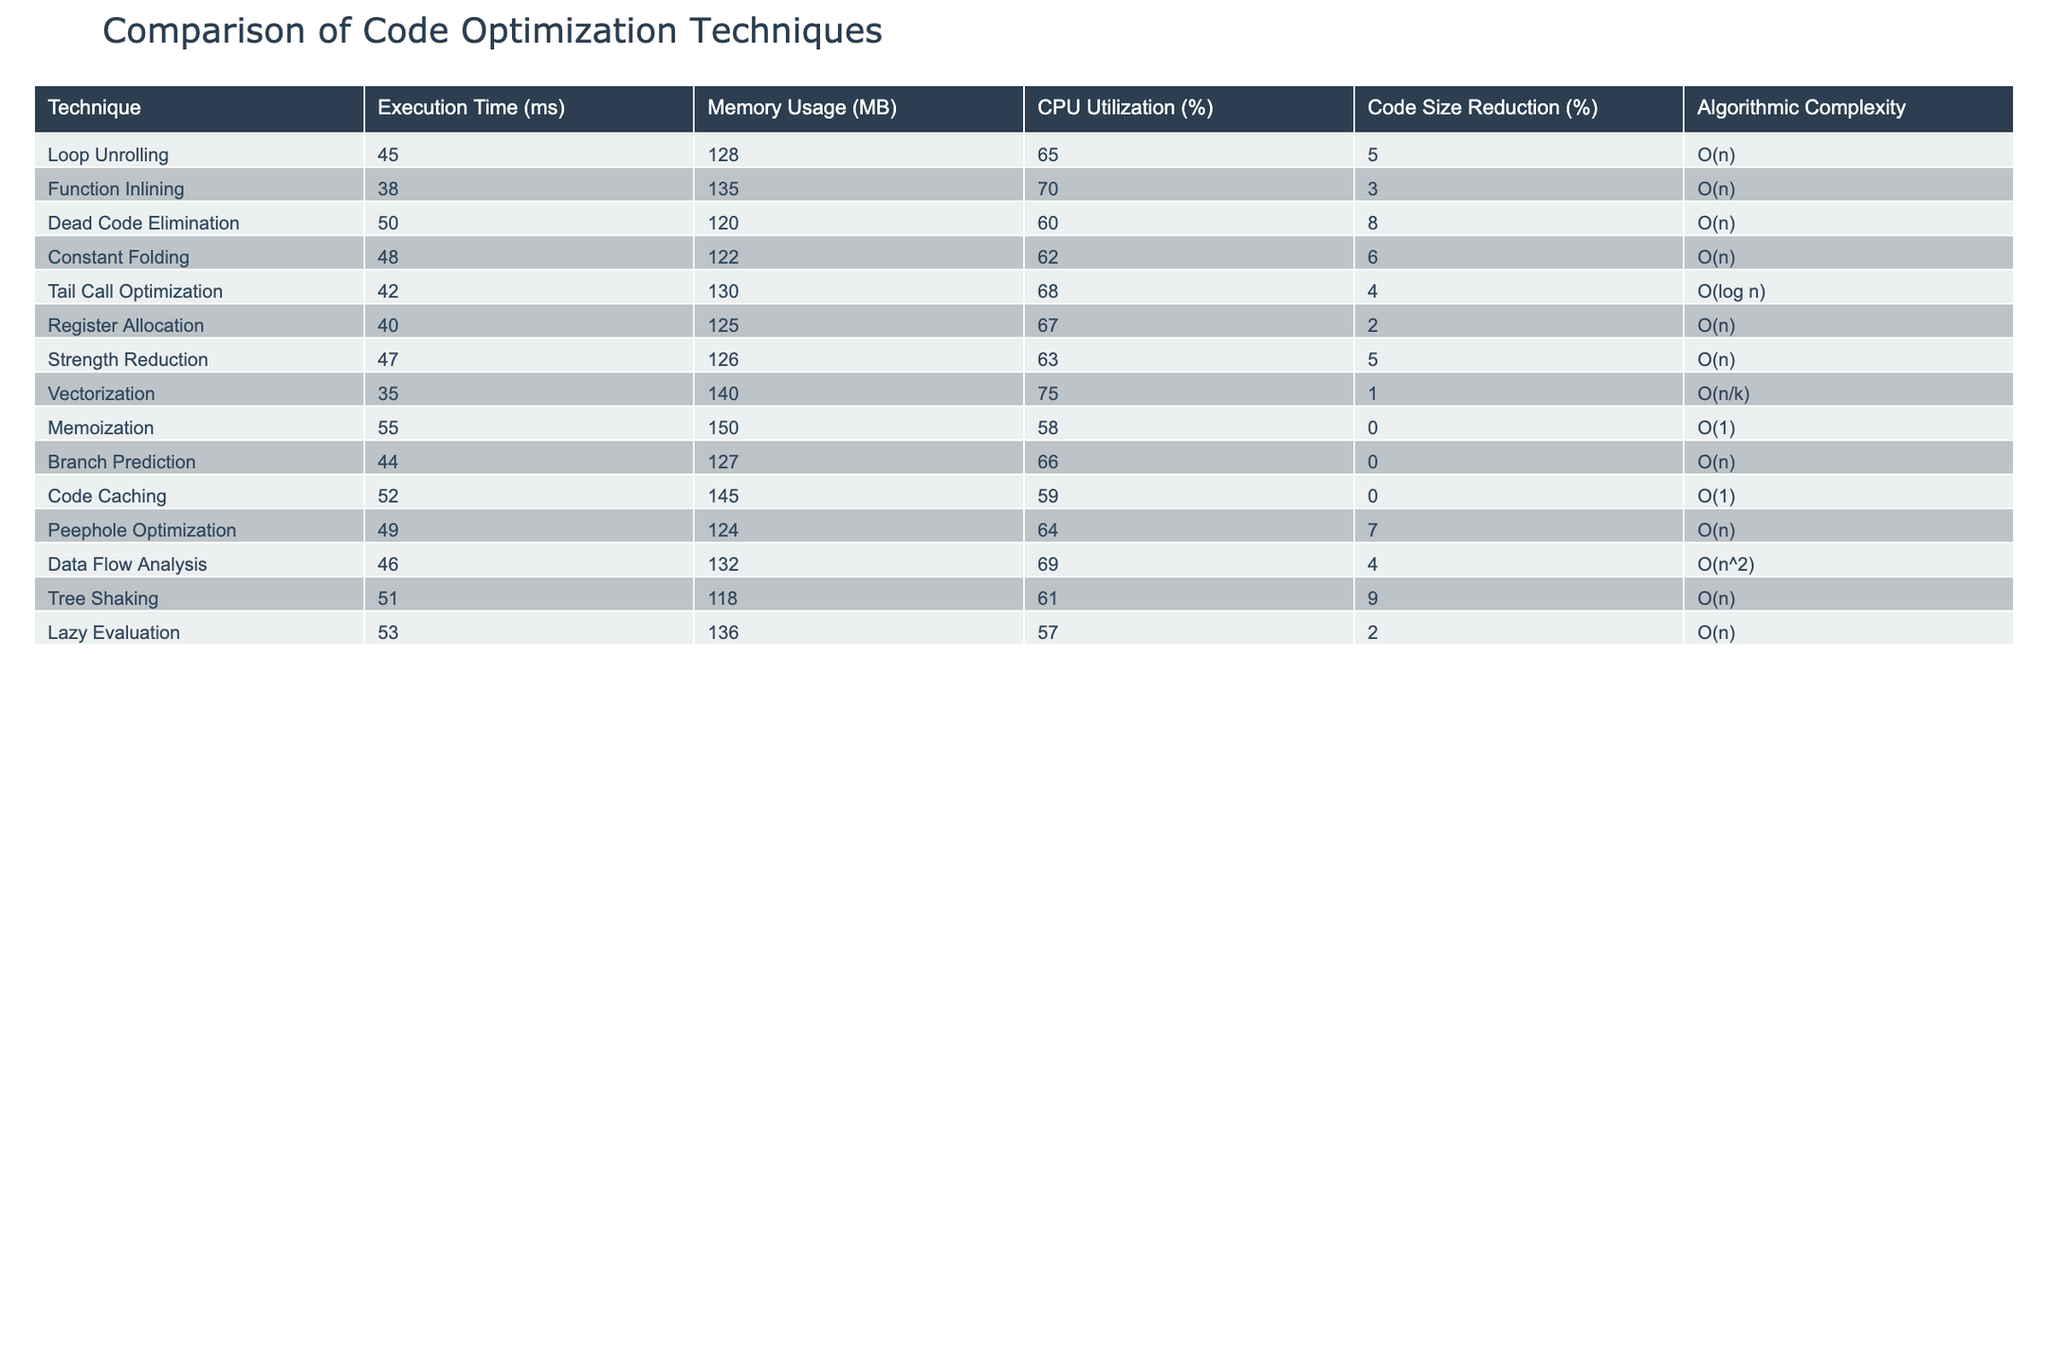What is the execution time of Function Inlining? The table shows that the execution time for Function Inlining is listed as 38 ms. Therefore, the answer is directly retrieved from the respective row.
Answer: 38 ms Which technique has the highest CPU utilization? By reviewing the CPU Utilization column, Vectorization has the highest value at 75%. This was determined by comparing all the values under the CPU Utilization header.
Answer: 75% What is the average execution time of all techniques? To find the average execution time, we sum all the execution times: (45 + 38 + 50 + 48 + 42 + 40 + 47 + 35 + 55 + 44 + 52 + 49 + 46 + 51 + 53) = 749 ms. Since there are 15 techniques, we divide 749 by 15, which gives the average. 749 / 15 = 49.93 ms, rounded to 50 ms.
Answer: 50 ms Is there a technique that has both the lowest execution time and lowest memory usage? Looking at the table, Vectorization has the lowest execution time (35 ms) and also has a relatively high memory usage (140 MB), so no technique shows both the lowest execution time and lowest memory usage simultaneously. This is verified by checking both the execution time and memory usage columns.
Answer: No Which techniques have an algorithmic complexity of O(n)? By filtering the table for the algorithmic complexity column, we find the techniques with O(n) are Loop Unrolling, Function Inlining, Dead Code Elimination, Constant Folding, Register Allocation, Strength Reduction, Branch Prediction, and Data Flow Analysis. This was done by evaluating each row's complexity value and listing those matching O(n).
Answer: Loop Unrolling, Function Inlining, Dead Code Elimination, Constant Folding, Register Allocation, Strength Reduction, Branch Prediction, Data Flow Analysis What is the sum of code size reductions for techniques with algorithmic complexity O(1)? The techniques with O(1) complexity are Memoization and Code Caching, which have code size reductions of 0% and 0% respectively. Summing these yields 0%. Therefore, the answer is reached by identifying the corresponding percentage changes.
Answer: 0% Which technique shows the biggest reduction in code size? Referring to the Code Size Reduction column in the table, Tree Shaking shows the highest reduction at 9%. This is derived from comparing all values in that column and identifying the maximum value.
Answer: 9% Does Tail Call Optimization have higher memory usage than Register Allocation? Comparing the memory usage, Tail Call Optimization uses 130 MB while Register Allocation uses 125 MB. Since 130 MB is greater than 125 MB, this can be validated by looking at the respective memory usage figures in their rows.
Answer: Yes 